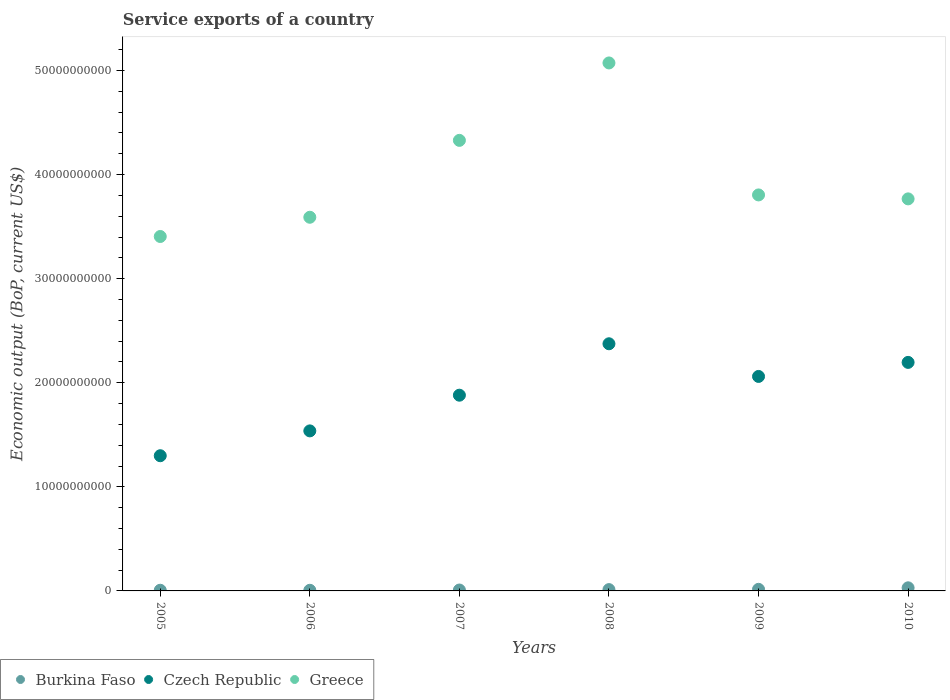What is the service exports in Czech Republic in 2009?
Make the answer very short. 2.06e+1. Across all years, what is the maximum service exports in Greece?
Provide a short and direct response. 5.07e+1. Across all years, what is the minimum service exports in Czech Republic?
Make the answer very short. 1.30e+1. In which year was the service exports in Greece maximum?
Ensure brevity in your answer.  2008. In which year was the service exports in Czech Republic minimum?
Provide a short and direct response. 2005. What is the total service exports in Czech Republic in the graph?
Provide a succinct answer. 1.13e+11. What is the difference between the service exports in Greece in 2005 and that in 2007?
Give a very brief answer. -9.24e+09. What is the difference between the service exports in Greece in 2009 and the service exports in Czech Republic in 2007?
Make the answer very short. 1.92e+1. What is the average service exports in Greece per year?
Make the answer very short. 3.99e+1. In the year 2006, what is the difference between the service exports in Greece and service exports in Burkina Faso?
Offer a terse response. 3.58e+1. What is the ratio of the service exports in Greece in 2006 to that in 2010?
Make the answer very short. 0.95. Is the service exports in Burkina Faso in 2006 less than that in 2010?
Keep it short and to the point. Yes. Is the difference between the service exports in Greece in 2005 and 2010 greater than the difference between the service exports in Burkina Faso in 2005 and 2010?
Provide a succinct answer. No. What is the difference between the highest and the second highest service exports in Greece?
Make the answer very short. 7.44e+09. What is the difference between the highest and the lowest service exports in Burkina Faso?
Provide a short and direct response. 2.38e+08. Is the sum of the service exports in Burkina Faso in 2008 and 2010 greater than the maximum service exports in Czech Republic across all years?
Offer a very short reply. No. Does the service exports in Czech Republic monotonically increase over the years?
Provide a succinct answer. No. What is the difference between two consecutive major ticks on the Y-axis?
Make the answer very short. 1.00e+1. How many legend labels are there?
Your response must be concise. 3. What is the title of the graph?
Your response must be concise. Service exports of a country. Does "Malaysia" appear as one of the legend labels in the graph?
Give a very brief answer. No. What is the label or title of the Y-axis?
Offer a very short reply. Economic output (BoP, current US$). What is the Economic output (BoP, current US$) of Burkina Faso in 2005?
Your response must be concise. 6.43e+07. What is the Economic output (BoP, current US$) of Czech Republic in 2005?
Your answer should be compact. 1.30e+1. What is the Economic output (BoP, current US$) in Greece in 2005?
Give a very brief answer. 3.41e+1. What is the Economic output (BoP, current US$) of Burkina Faso in 2006?
Ensure brevity in your answer.  6.05e+07. What is the Economic output (BoP, current US$) in Czech Republic in 2006?
Provide a short and direct response. 1.54e+1. What is the Economic output (BoP, current US$) in Greece in 2006?
Keep it short and to the point. 3.59e+1. What is the Economic output (BoP, current US$) in Burkina Faso in 2007?
Make the answer very short. 8.58e+07. What is the Economic output (BoP, current US$) in Czech Republic in 2007?
Your answer should be very brief. 1.88e+1. What is the Economic output (BoP, current US$) of Greece in 2007?
Ensure brevity in your answer.  4.33e+1. What is the Economic output (BoP, current US$) of Burkina Faso in 2008?
Make the answer very short. 1.26e+08. What is the Economic output (BoP, current US$) in Czech Republic in 2008?
Offer a very short reply. 2.37e+1. What is the Economic output (BoP, current US$) of Greece in 2008?
Offer a very short reply. 5.07e+1. What is the Economic output (BoP, current US$) of Burkina Faso in 2009?
Offer a very short reply. 1.53e+08. What is the Economic output (BoP, current US$) in Czech Republic in 2009?
Your answer should be compact. 2.06e+1. What is the Economic output (BoP, current US$) in Greece in 2009?
Make the answer very short. 3.80e+1. What is the Economic output (BoP, current US$) of Burkina Faso in 2010?
Offer a terse response. 2.98e+08. What is the Economic output (BoP, current US$) of Czech Republic in 2010?
Your answer should be very brief. 2.20e+1. What is the Economic output (BoP, current US$) of Greece in 2010?
Provide a short and direct response. 3.77e+1. Across all years, what is the maximum Economic output (BoP, current US$) in Burkina Faso?
Offer a very short reply. 2.98e+08. Across all years, what is the maximum Economic output (BoP, current US$) in Czech Republic?
Your answer should be compact. 2.37e+1. Across all years, what is the maximum Economic output (BoP, current US$) in Greece?
Make the answer very short. 5.07e+1. Across all years, what is the minimum Economic output (BoP, current US$) of Burkina Faso?
Keep it short and to the point. 6.05e+07. Across all years, what is the minimum Economic output (BoP, current US$) in Czech Republic?
Your response must be concise. 1.30e+1. Across all years, what is the minimum Economic output (BoP, current US$) in Greece?
Keep it short and to the point. 3.41e+1. What is the total Economic output (BoP, current US$) in Burkina Faso in the graph?
Your answer should be compact. 7.88e+08. What is the total Economic output (BoP, current US$) of Czech Republic in the graph?
Provide a succinct answer. 1.13e+11. What is the total Economic output (BoP, current US$) in Greece in the graph?
Provide a short and direct response. 2.40e+11. What is the difference between the Economic output (BoP, current US$) in Burkina Faso in 2005 and that in 2006?
Offer a very short reply. 3.81e+06. What is the difference between the Economic output (BoP, current US$) in Czech Republic in 2005 and that in 2006?
Provide a succinct answer. -2.39e+09. What is the difference between the Economic output (BoP, current US$) of Greece in 2005 and that in 2006?
Offer a very short reply. -1.85e+09. What is the difference between the Economic output (BoP, current US$) in Burkina Faso in 2005 and that in 2007?
Your answer should be compact. -2.15e+07. What is the difference between the Economic output (BoP, current US$) of Czech Republic in 2005 and that in 2007?
Offer a very short reply. -5.82e+09. What is the difference between the Economic output (BoP, current US$) in Greece in 2005 and that in 2007?
Provide a succinct answer. -9.24e+09. What is the difference between the Economic output (BoP, current US$) in Burkina Faso in 2005 and that in 2008?
Provide a short and direct response. -6.19e+07. What is the difference between the Economic output (BoP, current US$) of Czech Republic in 2005 and that in 2008?
Offer a terse response. -1.08e+1. What is the difference between the Economic output (BoP, current US$) in Greece in 2005 and that in 2008?
Your answer should be compact. -1.67e+1. What is the difference between the Economic output (BoP, current US$) in Burkina Faso in 2005 and that in 2009?
Your answer should be very brief. -8.85e+07. What is the difference between the Economic output (BoP, current US$) of Czech Republic in 2005 and that in 2009?
Your response must be concise. -7.62e+09. What is the difference between the Economic output (BoP, current US$) in Greece in 2005 and that in 2009?
Offer a very short reply. -3.99e+09. What is the difference between the Economic output (BoP, current US$) in Burkina Faso in 2005 and that in 2010?
Make the answer very short. -2.34e+08. What is the difference between the Economic output (BoP, current US$) of Czech Republic in 2005 and that in 2010?
Provide a succinct answer. -8.97e+09. What is the difference between the Economic output (BoP, current US$) of Greece in 2005 and that in 2010?
Your answer should be compact. -3.61e+09. What is the difference between the Economic output (BoP, current US$) in Burkina Faso in 2006 and that in 2007?
Provide a succinct answer. -2.53e+07. What is the difference between the Economic output (BoP, current US$) in Czech Republic in 2006 and that in 2007?
Keep it short and to the point. -3.43e+09. What is the difference between the Economic output (BoP, current US$) of Greece in 2006 and that in 2007?
Give a very brief answer. -7.39e+09. What is the difference between the Economic output (BoP, current US$) of Burkina Faso in 2006 and that in 2008?
Give a very brief answer. -6.57e+07. What is the difference between the Economic output (BoP, current US$) of Czech Republic in 2006 and that in 2008?
Make the answer very short. -8.37e+09. What is the difference between the Economic output (BoP, current US$) in Greece in 2006 and that in 2008?
Keep it short and to the point. -1.48e+1. What is the difference between the Economic output (BoP, current US$) in Burkina Faso in 2006 and that in 2009?
Make the answer very short. -9.23e+07. What is the difference between the Economic output (BoP, current US$) in Czech Republic in 2006 and that in 2009?
Your answer should be very brief. -5.23e+09. What is the difference between the Economic output (BoP, current US$) in Greece in 2006 and that in 2009?
Your answer should be compact. -2.15e+09. What is the difference between the Economic output (BoP, current US$) of Burkina Faso in 2006 and that in 2010?
Keep it short and to the point. -2.38e+08. What is the difference between the Economic output (BoP, current US$) of Czech Republic in 2006 and that in 2010?
Your answer should be compact. -6.58e+09. What is the difference between the Economic output (BoP, current US$) in Greece in 2006 and that in 2010?
Your answer should be very brief. -1.77e+09. What is the difference between the Economic output (BoP, current US$) of Burkina Faso in 2007 and that in 2008?
Ensure brevity in your answer.  -4.04e+07. What is the difference between the Economic output (BoP, current US$) of Czech Republic in 2007 and that in 2008?
Your response must be concise. -4.94e+09. What is the difference between the Economic output (BoP, current US$) of Greece in 2007 and that in 2008?
Ensure brevity in your answer.  -7.44e+09. What is the difference between the Economic output (BoP, current US$) of Burkina Faso in 2007 and that in 2009?
Provide a short and direct response. -6.71e+07. What is the difference between the Economic output (BoP, current US$) in Czech Republic in 2007 and that in 2009?
Offer a terse response. -1.80e+09. What is the difference between the Economic output (BoP, current US$) of Greece in 2007 and that in 2009?
Make the answer very short. 5.24e+09. What is the difference between the Economic output (BoP, current US$) of Burkina Faso in 2007 and that in 2010?
Offer a terse response. -2.12e+08. What is the difference between the Economic output (BoP, current US$) of Czech Republic in 2007 and that in 2010?
Make the answer very short. -3.15e+09. What is the difference between the Economic output (BoP, current US$) of Greece in 2007 and that in 2010?
Offer a terse response. 5.62e+09. What is the difference between the Economic output (BoP, current US$) in Burkina Faso in 2008 and that in 2009?
Your response must be concise. -2.66e+07. What is the difference between the Economic output (BoP, current US$) in Czech Republic in 2008 and that in 2009?
Provide a short and direct response. 3.14e+09. What is the difference between the Economic output (BoP, current US$) in Greece in 2008 and that in 2009?
Offer a very short reply. 1.27e+1. What is the difference between the Economic output (BoP, current US$) of Burkina Faso in 2008 and that in 2010?
Your response must be concise. -1.72e+08. What is the difference between the Economic output (BoP, current US$) of Czech Republic in 2008 and that in 2010?
Keep it short and to the point. 1.79e+09. What is the difference between the Economic output (BoP, current US$) of Greece in 2008 and that in 2010?
Keep it short and to the point. 1.31e+1. What is the difference between the Economic output (BoP, current US$) in Burkina Faso in 2009 and that in 2010?
Your response must be concise. -1.45e+08. What is the difference between the Economic output (BoP, current US$) of Czech Republic in 2009 and that in 2010?
Make the answer very short. -1.35e+09. What is the difference between the Economic output (BoP, current US$) of Greece in 2009 and that in 2010?
Make the answer very short. 3.80e+08. What is the difference between the Economic output (BoP, current US$) in Burkina Faso in 2005 and the Economic output (BoP, current US$) in Czech Republic in 2006?
Provide a short and direct response. -1.53e+1. What is the difference between the Economic output (BoP, current US$) of Burkina Faso in 2005 and the Economic output (BoP, current US$) of Greece in 2006?
Your answer should be compact. -3.58e+1. What is the difference between the Economic output (BoP, current US$) in Czech Republic in 2005 and the Economic output (BoP, current US$) in Greece in 2006?
Provide a short and direct response. -2.29e+1. What is the difference between the Economic output (BoP, current US$) of Burkina Faso in 2005 and the Economic output (BoP, current US$) of Czech Republic in 2007?
Ensure brevity in your answer.  -1.87e+1. What is the difference between the Economic output (BoP, current US$) in Burkina Faso in 2005 and the Economic output (BoP, current US$) in Greece in 2007?
Ensure brevity in your answer.  -4.32e+1. What is the difference between the Economic output (BoP, current US$) of Czech Republic in 2005 and the Economic output (BoP, current US$) of Greece in 2007?
Provide a succinct answer. -3.03e+1. What is the difference between the Economic output (BoP, current US$) in Burkina Faso in 2005 and the Economic output (BoP, current US$) in Czech Republic in 2008?
Make the answer very short. -2.37e+1. What is the difference between the Economic output (BoP, current US$) in Burkina Faso in 2005 and the Economic output (BoP, current US$) in Greece in 2008?
Your response must be concise. -5.07e+1. What is the difference between the Economic output (BoP, current US$) in Czech Republic in 2005 and the Economic output (BoP, current US$) in Greece in 2008?
Your response must be concise. -3.77e+1. What is the difference between the Economic output (BoP, current US$) in Burkina Faso in 2005 and the Economic output (BoP, current US$) in Czech Republic in 2009?
Offer a very short reply. -2.05e+1. What is the difference between the Economic output (BoP, current US$) of Burkina Faso in 2005 and the Economic output (BoP, current US$) of Greece in 2009?
Your answer should be very brief. -3.80e+1. What is the difference between the Economic output (BoP, current US$) of Czech Republic in 2005 and the Economic output (BoP, current US$) of Greece in 2009?
Provide a succinct answer. -2.51e+1. What is the difference between the Economic output (BoP, current US$) in Burkina Faso in 2005 and the Economic output (BoP, current US$) in Czech Republic in 2010?
Your answer should be very brief. -2.19e+1. What is the difference between the Economic output (BoP, current US$) of Burkina Faso in 2005 and the Economic output (BoP, current US$) of Greece in 2010?
Give a very brief answer. -3.76e+1. What is the difference between the Economic output (BoP, current US$) of Czech Republic in 2005 and the Economic output (BoP, current US$) of Greece in 2010?
Ensure brevity in your answer.  -2.47e+1. What is the difference between the Economic output (BoP, current US$) in Burkina Faso in 2006 and the Economic output (BoP, current US$) in Czech Republic in 2007?
Offer a very short reply. -1.87e+1. What is the difference between the Economic output (BoP, current US$) of Burkina Faso in 2006 and the Economic output (BoP, current US$) of Greece in 2007?
Your answer should be very brief. -4.32e+1. What is the difference between the Economic output (BoP, current US$) in Czech Republic in 2006 and the Economic output (BoP, current US$) in Greece in 2007?
Provide a short and direct response. -2.79e+1. What is the difference between the Economic output (BoP, current US$) of Burkina Faso in 2006 and the Economic output (BoP, current US$) of Czech Republic in 2008?
Your answer should be compact. -2.37e+1. What is the difference between the Economic output (BoP, current US$) of Burkina Faso in 2006 and the Economic output (BoP, current US$) of Greece in 2008?
Offer a very short reply. -5.07e+1. What is the difference between the Economic output (BoP, current US$) of Czech Republic in 2006 and the Economic output (BoP, current US$) of Greece in 2008?
Make the answer very short. -3.54e+1. What is the difference between the Economic output (BoP, current US$) of Burkina Faso in 2006 and the Economic output (BoP, current US$) of Czech Republic in 2009?
Offer a very short reply. -2.05e+1. What is the difference between the Economic output (BoP, current US$) of Burkina Faso in 2006 and the Economic output (BoP, current US$) of Greece in 2009?
Your answer should be compact. -3.80e+1. What is the difference between the Economic output (BoP, current US$) of Czech Republic in 2006 and the Economic output (BoP, current US$) of Greece in 2009?
Your answer should be compact. -2.27e+1. What is the difference between the Economic output (BoP, current US$) of Burkina Faso in 2006 and the Economic output (BoP, current US$) of Czech Republic in 2010?
Give a very brief answer. -2.19e+1. What is the difference between the Economic output (BoP, current US$) in Burkina Faso in 2006 and the Economic output (BoP, current US$) in Greece in 2010?
Provide a succinct answer. -3.76e+1. What is the difference between the Economic output (BoP, current US$) of Czech Republic in 2006 and the Economic output (BoP, current US$) of Greece in 2010?
Provide a succinct answer. -2.23e+1. What is the difference between the Economic output (BoP, current US$) in Burkina Faso in 2007 and the Economic output (BoP, current US$) in Czech Republic in 2008?
Your answer should be compact. -2.37e+1. What is the difference between the Economic output (BoP, current US$) of Burkina Faso in 2007 and the Economic output (BoP, current US$) of Greece in 2008?
Keep it short and to the point. -5.06e+1. What is the difference between the Economic output (BoP, current US$) of Czech Republic in 2007 and the Economic output (BoP, current US$) of Greece in 2008?
Provide a short and direct response. -3.19e+1. What is the difference between the Economic output (BoP, current US$) in Burkina Faso in 2007 and the Economic output (BoP, current US$) in Czech Republic in 2009?
Make the answer very short. -2.05e+1. What is the difference between the Economic output (BoP, current US$) of Burkina Faso in 2007 and the Economic output (BoP, current US$) of Greece in 2009?
Provide a short and direct response. -3.80e+1. What is the difference between the Economic output (BoP, current US$) of Czech Republic in 2007 and the Economic output (BoP, current US$) of Greece in 2009?
Offer a very short reply. -1.92e+1. What is the difference between the Economic output (BoP, current US$) in Burkina Faso in 2007 and the Economic output (BoP, current US$) in Czech Republic in 2010?
Make the answer very short. -2.19e+1. What is the difference between the Economic output (BoP, current US$) in Burkina Faso in 2007 and the Economic output (BoP, current US$) in Greece in 2010?
Your answer should be very brief. -3.76e+1. What is the difference between the Economic output (BoP, current US$) in Czech Republic in 2007 and the Economic output (BoP, current US$) in Greece in 2010?
Make the answer very short. -1.89e+1. What is the difference between the Economic output (BoP, current US$) of Burkina Faso in 2008 and the Economic output (BoP, current US$) of Czech Republic in 2009?
Ensure brevity in your answer.  -2.05e+1. What is the difference between the Economic output (BoP, current US$) in Burkina Faso in 2008 and the Economic output (BoP, current US$) in Greece in 2009?
Offer a very short reply. -3.79e+1. What is the difference between the Economic output (BoP, current US$) of Czech Republic in 2008 and the Economic output (BoP, current US$) of Greece in 2009?
Offer a terse response. -1.43e+1. What is the difference between the Economic output (BoP, current US$) in Burkina Faso in 2008 and the Economic output (BoP, current US$) in Czech Republic in 2010?
Ensure brevity in your answer.  -2.18e+1. What is the difference between the Economic output (BoP, current US$) in Burkina Faso in 2008 and the Economic output (BoP, current US$) in Greece in 2010?
Make the answer very short. -3.75e+1. What is the difference between the Economic output (BoP, current US$) of Czech Republic in 2008 and the Economic output (BoP, current US$) of Greece in 2010?
Ensure brevity in your answer.  -1.39e+1. What is the difference between the Economic output (BoP, current US$) of Burkina Faso in 2009 and the Economic output (BoP, current US$) of Czech Republic in 2010?
Your answer should be compact. -2.18e+1. What is the difference between the Economic output (BoP, current US$) in Burkina Faso in 2009 and the Economic output (BoP, current US$) in Greece in 2010?
Provide a succinct answer. -3.75e+1. What is the difference between the Economic output (BoP, current US$) of Czech Republic in 2009 and the Economic output (BoP, current US$) of Greece in 2010?
Give a very brief answer. -1.71e+1. What is the average Economic output (BoP, current US$) of Burkina Faso per year?
Offer a terse response. 1.31e+08. What is the average Economic output (BoP, current US$) of Czech Republic per year?
Offer a very short reply. 1.89e+1. What is the average Economic output (BoP, current US$) in Greece per year?
Your answer should be very brief. 3.99e+1. In the year 2005, what is the difference between the Economic output (BoP, current US$) in Burkina Faso and Economic output (BoP, current US$) in Czech Republic?
Provide a short and direct response. -1.29e+1. In the year 2005, what is the difference between the Economic output (BoP, current US$) in Burkina Faso and Economic output (BoP, current US$) in Greece?
Your answer should be compact. -3.40e+1. In the year 2005, what is the difference between the Economic output (BoP, current US$) in Czech Republic and Economic output (BoP, current US$) in Greece?
Provide a short and direct response. -2.11e+1. In the year 2006, what is the difference between the Economic output (BoP, current US$) in Burkina Faso and Economic output (BoP, current US$) in Czech Republic?
Offer a very short reply. -1.53e+1. In the year 2006, what is the difference between the Economic output (BoP, current US$) in Burkina Faso and Economic output (BoP, current US$) in Greece?
Give a very brief answer. -3.58e+1. In the year 2006, what is the difference between the Economic output (BoP, current US$) of Czech Republic and Economic output (BoP, current US$) of Greece?
Keep it short and to the point. -2.05e+1. In the year 2007, what is the difference between the Economic output (BoP, current US$) in Burkina Faso and Economic output (BoP, current US$) in Czech Republic?
Keep it short and to the point. -1.87e+1. In the year 2007, what is the difference between the Economic output (BoP, current US$) of Burkina Faso and Economic output (BoP, current US$) of Greece?
Your answer should be compact. -4.32e+1. In the year 2007, what is the difference between the Economic output (BoP, current US$) of Czech Republic and Economic output (BoP, current US$) of Greece?
Your answer should be very brief. -2.45e+1. In the year 2008, what is the difference between the Economic output (BoP, current US$) in Burkina Faso and Economic output (BoP, current US$) in Czech Republic?
Provide a succinct answer. -2.36e+1. In the year 2008, what is the difference between the Economic output (BoP, current US$) in Burkina Faso and Economic output (BoP, current US$) in Greece?
Ensure brevity in your answer.  -5.06e+1. In the year 2008, what is the difference between the Economic output (BoP, current US$) in Czech Republic and Economic output (BoP, current US$) in Greece?
Provide a succinct answer. -2.70e+1. In the year 2009, what is the difference between the Economic output (BoP, current US$) of Burkina Faso and Economic output (BoP, current US$) of Czech Republic?
Your answer should be compact. -2.05e+1. In the year 2009, what is the difference between the Economic output (BoP, current US$) in Burkina Faso and Economic output (BoP, current US$) in Greece?
Make the answer very short. -3.79e+1. In the year 2009, what is the difference between the Economic output (BoP, current US$) of Czech Republic and Economic output (BoP, current US$) of Greece?
Keep it short and to the point. -1.74e+1. In the year 2010, what is the difference between the Economic output (BoP, current US$) of Burkina Faso and Economic output (BoP, current US$) of Czech Republic?
Your response must be concise. -2.17e+1. In the year 2010, what is the difference between the Economic output (BoP, current US$) of Burkina Faso and Economic output (BoP, current US$) of Greece?
Ensure brevity in your answer.  -3.74e+1. In the year 2010, what is the difference between the Economic output (BoP, current US$) of Czech Republic and Economic output (BoP, current US$) of Greece?
Provide a succinct answer. -1.57e+1. What is the ratio of the Economic output (BoP, current US$) of Burkina Faso in 2005 to that in 2006?
Your response must be concise. 1.06. What is the ratio of the Economic output (BoP, current US$) of Czech Republic in 2005 to that in 2006?
Offer a terse response. 0.84. What is the ratio of the Economic output (BoP, current US$) in Greece in 2005 to that in 2006?
Your response must be concise. 0.95. What is the ratio of the Economic output (BoP, current US$) of Burkina Faso in 2005 to that in 2007?
Provide a succinct answer. 0.75. What is the ratio of the Economic output (BoP, current US$) of Czech Republic in 2005 to that in 2007?
Provide a succinct answer. 0.69. What is the ratio of the Economic output (BoP, current US$) in Greece in 2005 to that in 2007?
Provide a short and direct response. 0.79. What is the ratio of the Economic output (BoP, current US$) in Burkina Faso in 2005 to that in 2008?
Your answer should be very brief. 0.51. What is the ratio of the Economic output (BoP, current US$) in Czech Republic in 2005 to that in 2008?
Give a very brief answer. 0.55. What is the ratio of the Economic output (BoP, current US$) of Greece in 2005 to that in 2008?
Offer a terse response. 0.67. What is the ratio of the Economic output (BoP, current US$) of Burkina Faso in 2005 to that in 2009?
Provide a short and direct response. 0.42. What is the ratio of the Economic output (BoP, current US$) of Czech Republic in 2005 to that in 2009?
Give a very brief answer. 0.63. What is the ratio of the Economic output (BoP, current US$) in Greece in 2005 to that in 2009?
Offer a very short reply. 0.9. What is the ratio of the Economic output (BoP, current US$) in Burkina Faso in 2005 to that in 2010?
Offer a terse response. 0.22. What is the ratio of the Economic output (BoP, current US$) in Czech Republic in 2005 to that in 2010?
Keep it short and to the point. 0.59. What is the ratio of the Economic output (BoP, current US$) in Greece in 2005 to that in 2010?
Offer a terse response. 0.9. What is the ratio of the Economic output (BoP, current US$) of Burkina Faso in 2006 to that in 2007?
Offer a terse response. 0.71. What is the ratio of the Economic output (BoP, current US$) of Czech Republic in 2006 to that in 2007?
Offer a very short reply. 0.82. What is the ratio of the Economic output (BoP, current US$) of Greece in 2006 to that in 2007?
Make the answer very short. 0.83. What is the ratio of the Economic output (BoP, current US$) of Burkina Faso in 2006 to that in 2008?
Your response must be concise. 0.48. What is the ratio of the Economic output (BoP, current US$) of Czech Republic in 2006 to that in 2008?
Keep it short and to the point. 0.65. What is the ratio of the Economic output (BoP, current US$) of Greece in 2006 to that in 2008?
Give a very brief answer. 0.71. What is the ratio of the Economic output (BoP, current US$) of Burkina Faso in 2006 to that in 2009?
Give a very brief answer. 0.4. What is the ratio of the Economic output (BoP, current US$) of Czech Republic in 2006 to that in 2009?
Offer a terse response. 0.75. What is the ratio of the Economic output (BoP, current US$) in Greece in 2006 to that in 2009?
Offer a terse response. 0.94. What is the ratio of the Economic output (BoP, current US$) in Burkina Faso in 2006 to that in 2010?
Offer a terse response. 0.2. What is the ratio of the Economic output (BoP, current US$) of Czech Republic in 2006 to that in 2010?
Provide a short and direct response. 0.7. What is the ratio of the Economic output (BoP, current US$) in Greece in 2006 to that in 2010?
Make the answer very short. 0.95. What is the ratio of the Economic output (BoP, current US$) in Burkina Faso in 2007 to that in 2008?
Provide a succinct answer. 0.68. What is the ratio of the Economic output (BoP, current US$) in Czech Republic in 2007 to that in 2008?
Your response must be concise. 0.79. What is the ratio of the Economic output (BoP, current US$) in Greece in 2007 to that in 2008?
Give a very brief answer. 0.85. What is the ratio of the Economic output (BoP, current US$) in Burkina Faso in 2007 to that in 2009?
Provide a succinct answer. 0.56. What is the ratio of the Economic output (BoP, current US$) of Czech Republic in 2007 to that in 2009?
Your answer should be compact. 0.91. What is the ratio of the Economic output (BoP, current US$) in Greece in 2007 to that in 2009?
Your response must be concise. 1.14. What is the ratio of the Economic output (BoP, current US$) in Burkina Faso in 2007 to that in 2010?
Your answer should be compact. 0.29. What is the ratio of the Economic output (BoP, current US$) in Czech Republic in 2007 to that in 2010?
Offer a terse response. 0.86. What is the ratio of the Economic output (BoP, current US$) of Greece in 2007 to that in 2010?
Your answer should be very brief. 1.15. What is the ratio of the Economic output (BoP, current US$) in Burkina Faso in 2008 to that in 2009?
Make the answer very short. 0.83. What is the ratio of the Economic output (BoP, current US$) in Czech Republic in 2008 to that in 2009?
Ensure brevity in your answer.  1.15. What is the ratio of the Economic output (BoP, current US$) of Greece in 2008 to that in 2009?
Ensure brevity in your answer.  1.33. What is the ratio of the Economic output (BoP, current US$) in Burkina Faso in 2008 to that in 2010?
Provide a succinct answer. 0.42. What is the ratio of the Economic output (BoP, current US$) of Czech Republic in 2008 to that in 2010?
Offer a terse response. 1.08. What is the ratio of the Economic output (BoP, current US$) in Greece in 2008 to that in 2010?
Provide a short and direct response. 1.35. What is the ratio of the Economic output (BoP, current US$) of Burkina Faso in 2009 to that in 2010?
Provide a succinct answer. 0.51. What is the ratio of the Economic output (BoP, current US$) in Czech Republic in 2009 to that in 2010?
Give a very brief answer. 0.94. What is the difference between the highest and the second highest Economic output (BoP, current US$) in Burkina Faso?
Your response must be concise. 1.45e+08. What is the difference between the highest and the second highest Economic output (BoP, current US$) of Czech Republic?
Your answer should be very brief. 1.79e+09. What is the difference between the highest and the second highest Economic output (BoP, current US$) of Greece?
Make the answer very short. 7.44e+09. What is the difference between the highest and the lowest Economic output (BoP, current US$) in Burkina Faso?
Offer a terse response. 2.38e+08. What is the difference between the highest and the lowest Economic output (BoP, current US$) of Czech Republic?
Offer a very short reply. 1.08e+1. What is the difference between the highest and the lowest Economic output (BoP, current US$) in Greece?
Your answer should be compact. 1.67e+1. 